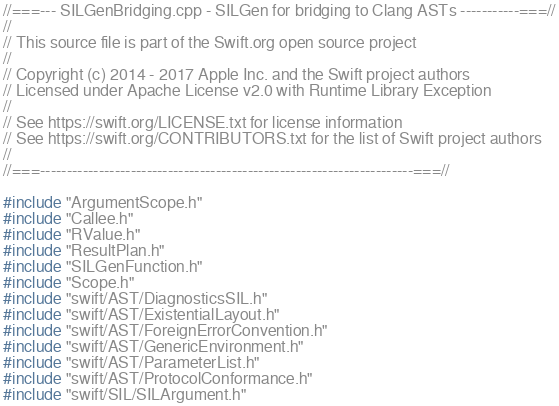Convert code to text. <code><loc_0><loc_0><loc_500><loc_500><_C++_>//===--- SILGenBridging.cpp - SILGen for bridging to Clang ASTs -----------===//
//
// This source file is part of the Swift.org open source project
//
// Copyright (c) 2014 - 2017 Apple Inc. and the Swift project authors
// Licensed under Apache License v2.0 with Runtime Library Exception
//
// See https://swift.org/LICENSE.txt for license information
// See https://swift.org/CONTRIBUTORS.txt for the list of Swift project authors
//
//===----------------------------------------------------------------------===//

#include "ArgumentScope.h"
#include "Callee.h"
#include "RValue.h"
#include "ResultPlan.h"
#include "SILGenFunction.h"
#include "Scope.h"
#include "swift/AST/DiagnosticsSIL.h"
#include "swift/AST/ExistentialLayout.h"
#include "swift/AST/ForeignErrorConvention.h"
#include "swift/AST/GenericEnvironment.h"
#include "swift/AST/ParameterList.h"
#include "swift/AST/ProtocolConformance.h"
#include "swift/SIL/SILArgument.h"</code> 